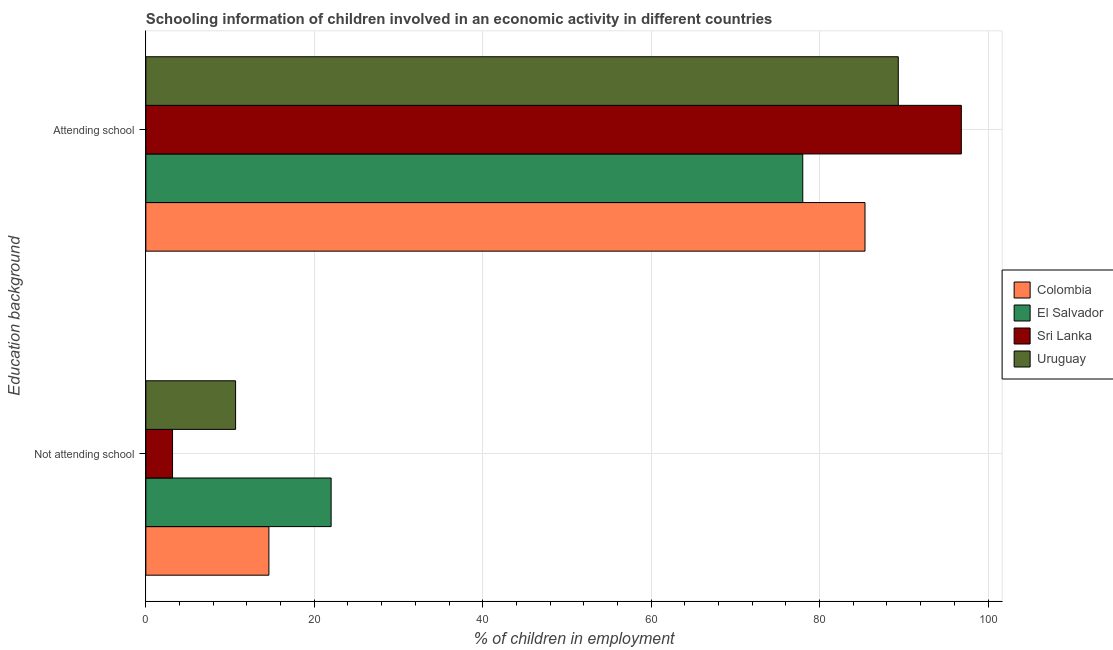How many different coloured bars are there?
Offer a very short reply. 4. Are the number of bars per tick equal to the number of legend labels?
Make the answer very short. Yes. How many bars are there on the 2nd tick from the top?
Ensure brevity in your answer.  4. What is the label of the 1st group of bars from the top?
Provide a short and direct response. Attending school. What is the percentage of employed children who are attending school in Sri Lanka?
Your answer should be very brief. 96.83. Across all countries, what is the maximum percentage of employed children who are attending school?
Your response must be concise. 96.83. Across all countries, what is the minimum percentage of employed children who are attending school?
Keep it short and to the point. 78. In which country was the percentage of employed children who are not attending school maximum?
Offer a terse response. El Salvador. In which country was the percentage of employed children who are not attending school minimum?
Keep it short and to the point. Sri Lanka. What is the total percentage of employed children who are attending school in the graph?
Provide a succinct answer. 349.56. What is the difference between the percentage of employed children who are attending school in El Salvador and that in Colombia?
Offer a terse response. -7.39. What is the difference between the percentage of employed children who are not attending school in Sri Lanka and the percentage of employed children who are attending school in El Salvador?
Offer a terse response. -74.83. What is the average percentage of employed children who are attending school per country?
Make the answer very short. 87.39. What is the difference between the percentage of employed children who are attending school and percentage of employed children who are not attending school in Sri Lanka?
Give a very brief answer. 93.66. In how many countries, is the percentage of employed children who are not attending school greater than 8 %?
Make the answer very short. 3. What is the ratio of the percentage of employed children who are not attending school in Sri Lanka to that in El Salvador?
Make the answer very short. 0.14. Is the percentage of employed children who are not attending school in El Salvador less than that in Colombia?
Your response must be concise. No. What does the 1st bar from the top in Not attending school represents?
Provide a succinct answer. Uruguay. What does the 4th bar from the bottom in Attending school represents?
Provide a short and direct response. Uruguay. How many bars are there?
Give a very brief answer. 8. What is the difference between two consecutive major ticks on the X-axis?
Offer a very short reply. 20. Are the values on the major ticks of X-axis written in scientific E-notation?
Ensure brevity in your answer.  No. Does the graph contain any zero values?
Provide a succinct answer. No. Does the graph contain grids?
Offer a very short reply. Yes. Where does the legend appear in the graph?
Provide a short and direct response. Center right. What is the title of the graph?
Offer a very short reply. Schooling information of children involved in an economic activity in different countries. What is the label or title of the X-axis?
Offer a terse response. % of children in employment. What is the label or title of the Y-axis?
Offer a terse response. Education background. What is the % of children in employment in Colombia in Not attending school?
Your response must be concise. 14.61. What is the % of children in employment in El Salvador in Not attending school?
Your answer should be compact. 22. What is the % of children in employment of Sri Lanka in Not attending school?
Your response must be concise. 3.17. What is the % of children in employment of Uruguay in Not attending school?
Your answer should be very brief. 10.66. What is the % of children in employment of Colombia in Attending school?
Your response must be concise. 85.39. What is the % of children in employment of El Salvador in Attending school?
Ensure brevity in your answer.  78. What is the % of children in employment of Sri Lanka in Attending school?
Make the answer very short. 96.83. What is the % of children in employment in Uruguay in Attending school?
Your answer should be compact. 89.34. Across all Education background, what is the maximum % of children in employment in Colombia?
Your answer should be compact. 85.39. Across all Education background, what is the maximum % of children in employment of Sri Lanka?
Offer a terse response. 96.83. Across all Education background, what is the maximum % of children in employment in Uruguay?
Keep it short and to the point. 89.34. Across all Education background, what is the minimum % of children in employment of Colombia?
Offer a terse response. 14.61. Across all Education background, what is the minimum % of children in employment of Sri Lanka?
Offer a very short reply. 3.17. Across all Education background, what is the minimum % of children in employment in Uruguay?
Your answer should be very brief. 10.66. What is the total % of children in employment of Colombia in the graph?
Your response must be concise. 100. What is the total % of children in employment of El Salvador in the graph?
Keep it short and to the point. 100. What is the total % of children in employment in Uruguay in the graph?
Make the answer very short. 100. What is the difference between the % of children in employment in Colombia in Not attending school and that in Attending school?
Your answer should be compact. -70.78. What is the difference between the % of children in employment in El Salvador in Not attending school and that in Attending school?
Your response must be concise. -56. What is the difference between the % of children in employment in Sri Lanka in Not attending school and that in Attending school?
Make the answer very short. -93.66. What is the difference between the % of children in employment of Uruguay in Not attending school and that in Attending school?
Provide a short and direct response. -78.68. What is the difference between the % of children in employment in Colombia in Not attending school and the % of children in employment in El Salvador in Attending school?
Offer a terse response. -63.39. What is the difference between the % of children in employment of Colombia in Not attending school and the % of children in employment of Sri Lanka in Attending school?
Your answer should be very brief. -82.22. What is the difference between the % of children in employment of Colombia in Not attending school and the % of children in employment of Uruguay in Attending school?
Offer a terse response. -74.73. What is the difference between the % of children in employment in El Salvador in Not attending school and the % of children in employment in Sri Lanka in Attending school?
Your answer should be compact. -74.83. What is the difference between the % of children in employment of El Salvador in Not attending school and the % of children in employment of Uruguay in Attending school?
Give a very brief answer. -67.34. What is the difference between the % of children in employment in Sri Lanka in Not attending school and the % of children in employment in Uruguay in Attending school?
Ensure brevity in your answer.  -86.17. What is the average % of children in employment in Colombia per Education background?
Your answer should be compact. 50. What is the average % of children in employment of El Salvador per Education background?
Make the answer very short. 50. What is the average % of children in employment in Sri Lanka per Education background?
Offer a terse response. 50. What is the average % of children in employment of Uruguay per Education background?
Provide a short and direct response. 50. What is the difference between the % of children in employment of Colombia and % of children in employment of El Salvador in Not attending school?
Ensure brevity in your answer.  -7.39. What is the difference between the % of children in employment in Colombia and % of children in employment in Sri Lanka in Not attending school?
Give a very brief answer. 11.44. What is the difference between the % of children in employment of Colombia and % of children in employment of Uruguay in Not attending school?
Your answer should be compact. 3.95. What is the difference between the % of children in employment of El Salvador and % of children in employment of Sri Lanka in Not attending school?
Make the answer very short. 18.83. What is the difference between the % of children in employment in El Salvador and % of children in employment in Uruguay in Not attending school?
Make the answer very short. 11.34. What is the difference between the % of children in employment in Sri Lanka and % of children in employment in Uruguay in Not attending school?
Keep it short and to the point. -7.49. What is the difference between the % of children in employment in Colombia and % of children in employment in El Salvador in Attending school?
Your answer should be compact. 7.39. What is the difference between the % of children in employment of Colombia and % of children in employment of Sri Lanka in Attending school?
Offer a terse response. -11.44. What is the difference between the % of children in employment of Colombia and % of children in employment of Uruguay in Attending school?
Ensure brevity in your answer.  -3.95. What is the difference between the % of children in employment in El Salvador and % of children in employment in Sri Lanka in Attending school?
Provide a succinct answer. -18.83. What is the difference between the % of children in employment of El Salvador and % of children in employment of Uruguay in Attending school?
Keep it short and to the point. -11.34. What is the difference between the % of children in employment in Sri Lanka and % of children in employment in Uruguay in Attending school?
Your answer should be compact. 7.49. What is the ratio of the % of children in employment in Colombia in Not attending school to that in Attending school?
Make the answer very short. 0.17. What is the ratio of the % of children in employment of El Salvador in Not attending school to that in Attending school?
Ensure brevity in your answer.  0.28. What is the ratio of the % of children in employment in Sri Lanka in Not attending school to that in Attending school?
Offer a very short reply. 0.03. What is the ratio of the % of children in employment of Uruguay in Not attending school to that in Attending school?
Your answer should be compact. 0.12. What is the difference between the highest and the second highest % of children in employment of Colombia?
Provide a short and direct response. 70.78. What is the difference between the highest and the second highest % of children in employment of Sri Lanka?
Provide a short and direct response. 93.66. What is the difference between the highest and the second highest % of children in employment in Uruguay?
Give a very brief answer. 78.68. What is the difference between the highest and the lowest % of children in employment of Colombia?
Your response must be concise. 70.78. What is the difference between the highest and the lowest % of children in employment in Sri Lanka?
Provide a short and direct response. 93.66. What is the difference between the highest and the lowest % of children in employment in Uruguay?
Your answer should be compact. 78.68. 